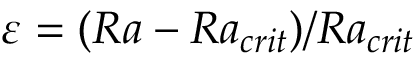<formula> <loc_0><loc_0><loc_500><loc_500>\varepsilon = ( R a - R a _ { c r i t } ) / R a _ { c r i t }</formula> 